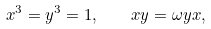<formula> <loc_0><loc_0><loc_500><loc_500>x ^ { 3 } = y ^ { 3 } = 1 , \quad x y = \omega y x ,</formula> 